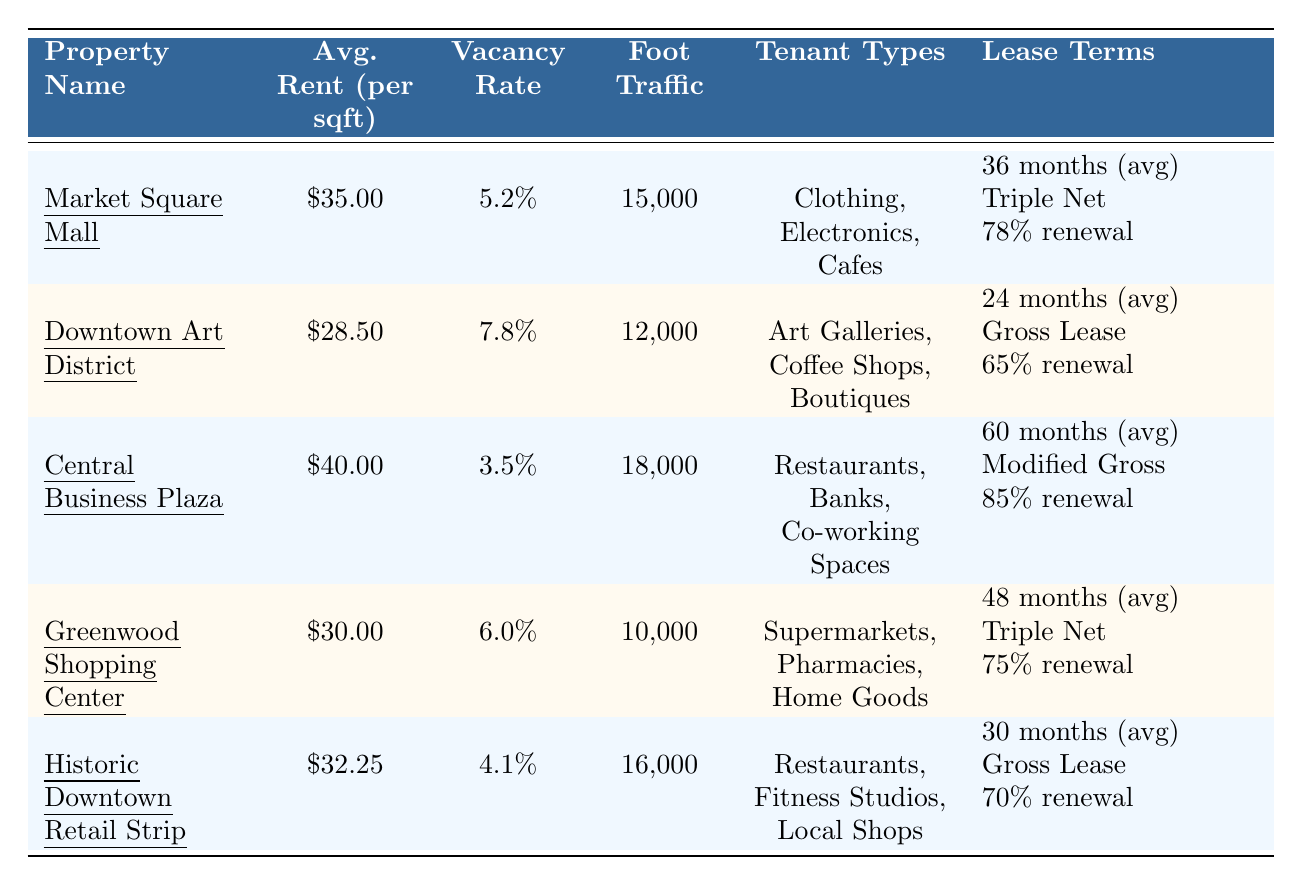What is the average rent per square foot for Market Square Mall? The table shows that the average rent per square foot for Market Square Mall is listed as $35.00.
Answer: $35.00 What is the vacancy rate for Central Business Plaza? According to the table, the vacancy rate for Central Business Plaza is 3.5%.
Answer: 3.5% Which property has the highest foot traffic? The table indicates that Central Business Plaza has the highest foot traffic at 18,000 visitors.
Answer: Central Business Plaza How many months on average is the lease term for Downtown Art District? The table states that the average lease term for Downtown Art District is 24 months.
Answer: 24 months What is the renewal rate for tenants at Greenwood Shopping Center? The table shows that the renewal rate for tenants at Greenwood Shopping Center is 75%.
Answer: 75% Which property type has the lowest average rent per square foot? Looking at the average rent prices, Downtown Art District has the lowest average rent at $28.50 per square foot.
Answer: Downtown Art District Calculate the average vacancy rate of all properties listed in the table. To find the average vacancy rate, we sum up the rates: (5.2 + 7.8 + 3.5 + 6.0 + 4.1) = 26.6%. Then we divide by the number of properties (5): 26.6 / 5 = 5.32%.
Answer: 5.32% Is the average rent per square foot at Historic Downtown Retail Strip higher or lower than that of Greenwood Shopping Center? The average rent at Historic Downtown Retail Strip is $32.25, while Greenwood Shopping Center is $30.00. Since $32.25 is greater than $30.00, it is higher.
Answer: Higher What are the tenant types available at Central Business Plaza? The table indicates that Central Business Plaza has tenant types including Restaurants, Banks, and Co-working Spaces.
Answer: Restaurants, Banks, Co-working Spaces Which property has a lower renewal rate, Downtown Art District or Historic Downtown Retail Strip? The renewal rate for Downtown Art District is 65%, and for Historic Downtown Retail Strip, it is 70%. Since 65% is less than 70%, Downtown Art District has the lower renewal rate.
Answer: Downtown Art District 